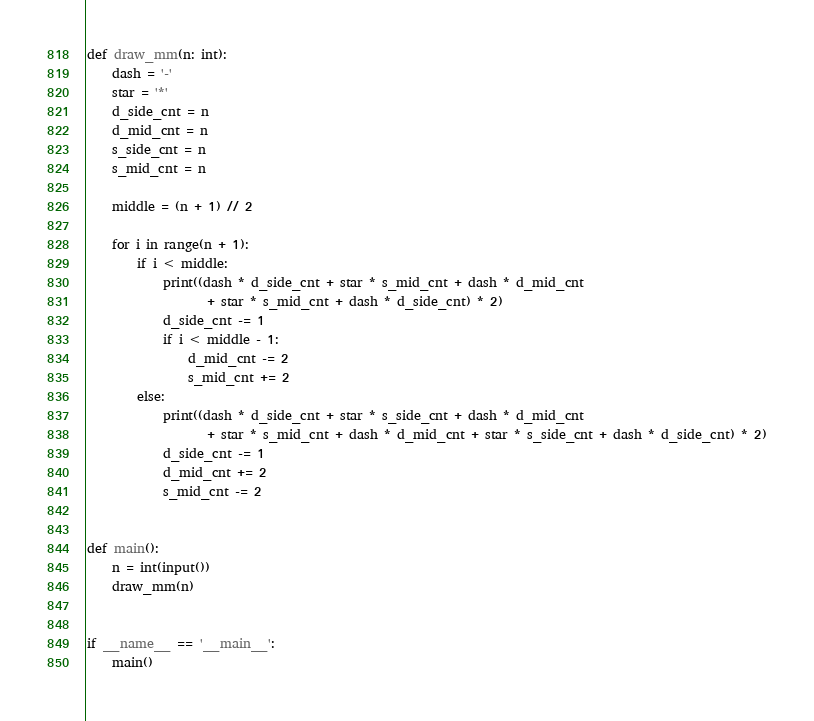<code> <loc_0><loc_0><loc_500><loc_500><_Python_>def draw_mm(n: int):
    dash = '-'
    star = '*'
    d_side_cnt = n
    d_mid_cnt = n
    s_side_cnt = n
    s_mid_cnt = n

    middle = (n + 1) // 2

    for i in range(n + 1):
        if i < middle:
            print((dash * d_side_cnt + star * s_mid_cnt + dash * d_mid_cnt
                   + star * s_mid_cnt + dash * d_side_cnt) * 2)
            d_side_cnt -= 1
            if i < middle - 1:
                d_mid_cnt -= 2
                s_mid_cnt += 2
        else:
            print((dash * d_side_cnt + star * s_side_cnt + dash * d_mid_cnt
                   + star * s_mid_cnt + dash * d_mid_cnt + star * s_side_cnt + dash * d_side_cnt) * 2)
            d_side_cnt -= 1
            d_mid_cnt += 2
            s_mid_cnt -= 2


def main():
    n = int(input())
    draw_mm(n)


if __name__ == '__main__':
    main()
</code> 